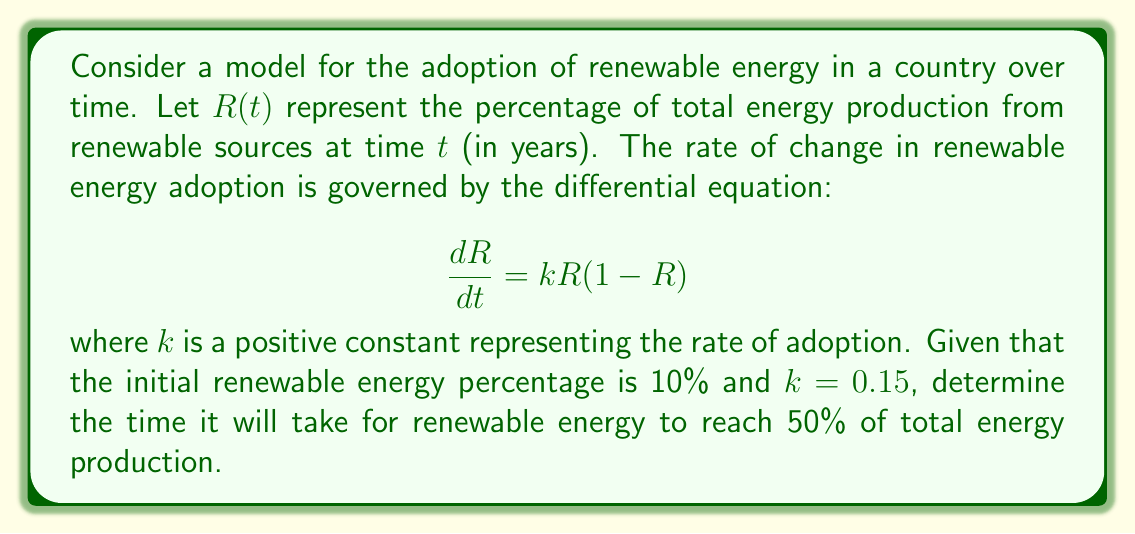Provide a solution to this math problem. To solve this problem, we'll follow these steps:

1) The given differential equation is a logistic growth model, which is appropriate for modeling adoption processes.

2) We need to solve the differential equation:

   $$\frac{dR}{dt} = k R(1-R)$$

3) The solution to this logistic equation is:

   $$R(t) = \frac{1}{1 + Ce^{-kt}}$$

   where $C$ is a constant determined by the initial condition.

4) Given the initial condition $R(0) = 0.1$, we can find $C$:

   $$0.1 = \frac{1}{1 + C}$$
   $$C = 9$$

5) Now our specific solution is:

   $$R(t) = \frac{1}{1 + 9e^{-0.15t}}$$

6) We want to find $t$ when $R(t) = 0.5$. Let's substitute this:

   $$0.5 = \frac{1}{1 + 9e^{-0.15t}}$$

7) Solving for $t$:

   $$1 + 9e^{-0.15t} = 2$$
   $$9e^{-0.15t} = 1$$
   $$e^{-0.15t} = \frac{1}{9}$$
   $$-0.15t = \ln(\frac{1}{9}) = -\ln(9)$$
   $$t = \frac{\ln(9)}{0.15}$$

8) Calculate the final value:

   $$t \approx 14.62$$

Therefore, it will take approximately 14.62 years for renewable energy to reach 50% of total energy production.
Answer: 14.62 years 